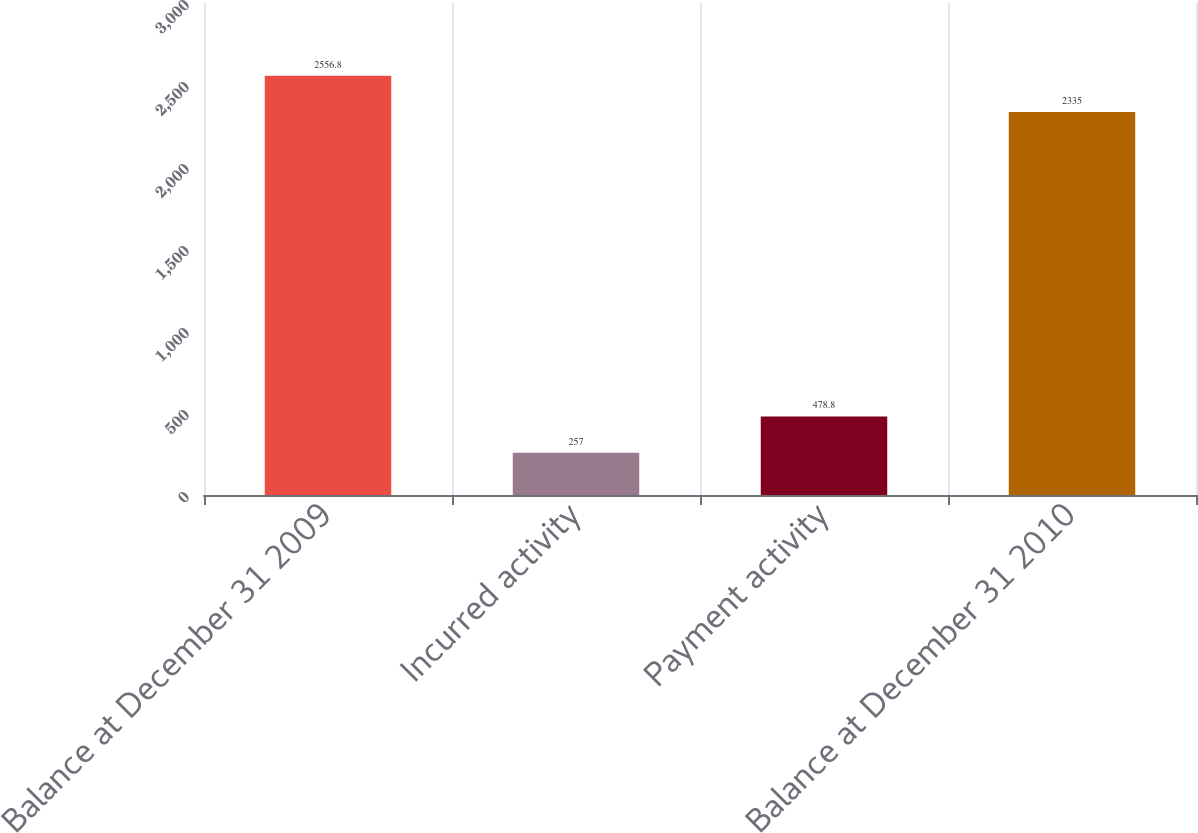Convert chart. <chart><loc_0><loc_0><loc_500><loc_500><bar_chart><fcel>Balance at December 31 2009<fcel>Incurred activity<fcel>Payment activity<fcel>Balance at December 31 2010<nl><fcel>2556.8<fcel>257<fcel>478.8<fcel>2335<nl></chart> 